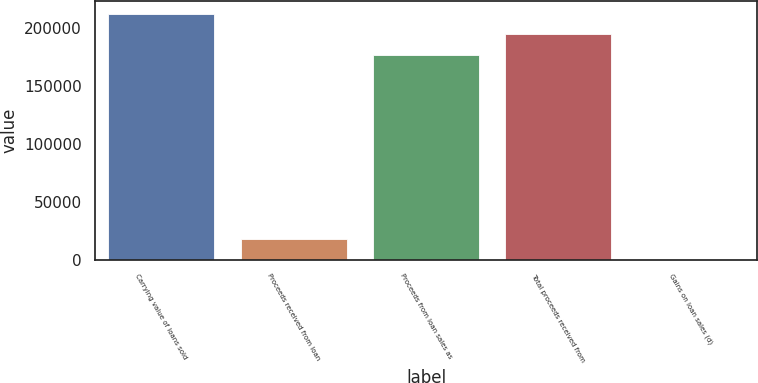Convert chart. <chart><loc_0><loc_0><loc_500><loc_500><bar_chart><fcel>Carrying value of loans sold<fcel>Proceeds received from loan<fcel>Proceeds from loan sales as<fcel>Total proceeds received from<fcel>Gains on loan sales (d)<nl><fcel>212365<fcel>18027.7<fcel>176592<fcel>194479<fcel>141<nl></chart> 